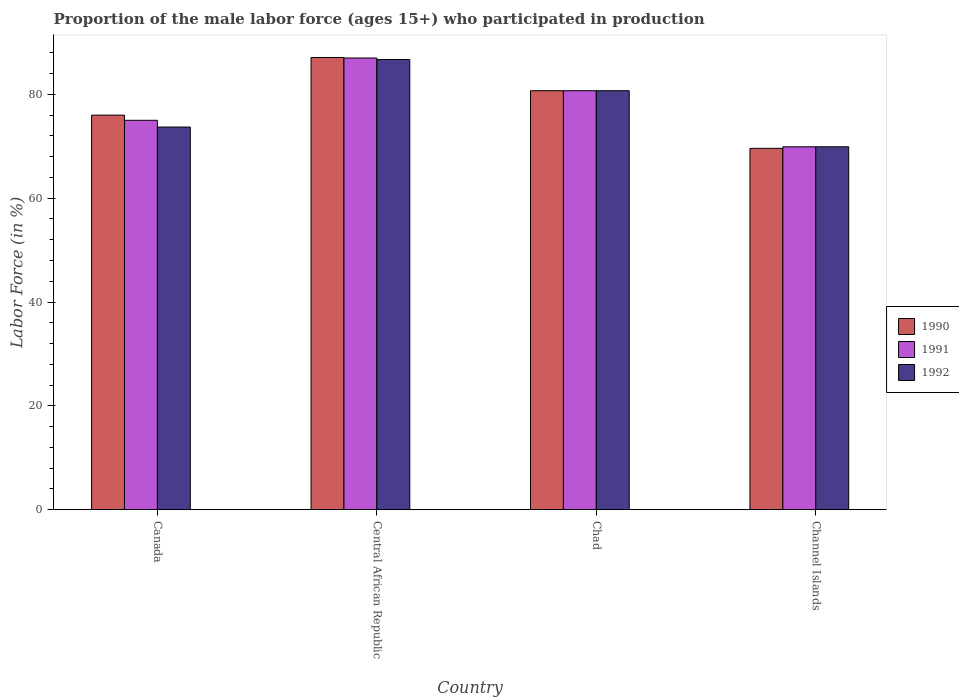How many different coloured bars are there?
Offer a very short reply. 3. How many groups of bars are there?
Your response must be concise. 4. How many bars are there on the 3rd tick from the right?
Keep it short and to the point. 3. What is the label of the 1st group of bars from the left?
Offer a very short reply. Canada. In how many cases, is the number of bars for a given country not equal to the number of legend labels?
Your answer should be compact. 0. What is the proportion of the male labor force who participated in production in 1992 in Chad?
Your answer should be compact. 80.7. Across all countries, what is the minimum proportion of the male labor force who participated in production in 1992?
Ensure brevity in your answer.  69.9. In which country was the proportion of the male labor force who participated in production in 1991 maximum?
Offer a terse response. Central African Republic. In which country was the proportion of the male labor force who participated in production in 1992 minimum?
Offer a terse response. Channel Islands. What is the total proportion of the male labor force who participated in production in 1990 in the graph?
Make the answer very short. 313.4. What is the difference between the proportion of the male labor force who participated in production in 1992 in Canada and that in Chad?
Your answer should be compact. -7. What is the difference between the proportion of the male labor force who participated in production in 1990 in Chad and the proportion of the male labor force who participated in production in 1991 in Central African Republic?
Your response must be concise. -6.3. What is the average proportion of the male labor force who participated in production in 1990 per country?
Your response must be concise. 78.35. What is the difference between the proportion of the male labor force who participated in production of/in 1992 and proportion of the male labor force who participated in production of/in 1991 in Central African Republic?
Offer a terse response. -0.3. In how many countries, is the proportion of the male labor force who participated in production in 1992 greater than 8 %?
Offer a terse response. 4. What is the ratio of the proportion of the male labor force who participated in production in 1991 in Canada to that in Central African Republic?
Keep it short and to the point. 0.86. Is the proportion of the male labor force who participated in production in 1991 in Canada less than that in Central African Republic?
Ensure brevity in your answer.  Yes. Is the difference between the proportion of the male labor force who participated in production in 1992 in Central African Republic and Chad greater than the difference between the proportion of the male labor force who participated in production in 1991 in Central African Republic and Chad?
Offer a very short reply. No. What is the difference between the highest and the second highest proportion of the male labor force who participated in production in 1992?
Provide a succinct answer. 7. What is the difference between the highest and the lowest proportion of the male labor force who participated in production in 1990?
Offer a very short reply. 17.5. Is the sum of the proportion of the male labor force who participated in production in 1992 in Canada and Channel Islands greater than the maximum proportion of the male labor force who participated in production in 1990 across all countries?
Ensure brevity in your answer.  Yes. What does the 3rd bar from the right in Central African Republic represents?
Your answer should be compact. 1990. How many bars are there?
Provide a succinct answer. 12. What is the difference between two consecutive major ticks on the Y-axis?
Your response must be concise. 20. Are the values on the major ticks of Y-axis written in scientific E-notation?
Offer a very short reply. No. Does the graph contain grids?
Offer a very short reply. No. Where does the legend appear in the graph?
Offer a terse response. Center right. How many legend labels are there?
Your response must be concise. 3. What is the title of the graph?
Give a very brief answer. Proportion of the male labor force (ages 15+) who participated in production. What is the Labor Force (in %) in 1992 in Canada?
Your answer should be very brief. 73.7. What is the Labor Force (in %) in 1990 in Central African Republic?
Give a very brief answer. 87.1. What is the Labor Force (in %) in 1991 in Central African Republic?
Keep it short and to the point. 87. What is the Labor Force (in %) of 1992 in Central African Republic?
Your response must be concise. 86.7. What is the Labor Force (in %) of 1990 in Chad?
Ensure brevity in your answer.  80.7. What is the Labor Force (in %) of 1991 in Chad?
Provide a succinct answer. 80.7. What is the Labor Force (in %) in 1992 in Chad?
Provide a succinct answer. 80.7. What is the Labor Force (in %) in 1990 in Channel Islands?
Provide a succinct answer. 69.6. What is the Labor Force (in %) of 1991 in Channel Islands?
Give a very brief answer. 69.9. What is the Labor Force (in %) in 1992 in Channel Islands?
Provide a short and direct response. 69.9. Across all countries, what is the maximum Labor Force (in %) in 1990?
Provide a succinct answer. 87.1. Across all countries, what is the maximum Labor Force (in %) of 1991?
Keep it short and to the point. 87. Across all countries, what is the maximum Labor Force (in %) in 1992?
Your answer should be very brief. 86.7. Across all countries, what is the minimum Labor Force (in %) in 1990?
Provide a succinct answer. 69.6. Across all countries, what is the minimum Labor Force (in %) of 1991?
Keep it short and to the point. 69.9. Across all countries, what is the minimum Labor Force (in %) of 1992?
Give a very brief answer. 69.9. What is the total Labor Force (in %) in 1990 in the graph?
Your answer should be very brief. 313.4. What is the total Labor Force (in %) in 1991 in the graph?
Offer a terse response. 312.6. What is the total Labor Force (in %) in 1992 in the graph?
Your answer should be very brief. 311. What is the difference between the Labor Force (in %) of 1991 in Canada and that in Central African Republic?
Keep it short and to the point. -12. What is the difference between the Labor Force (in %) in 1992 in Canada and that in Channel Islands?
Make the answer very short. 3.8. What is the difference between the Labor Force (in %) in 1991 in Central African Republic and that in Chad?
Keep it short and to the point. 6.3. What is the difference between the Labor Force (in %) in 1992 in Central African Republic and that in Chad?
Your answer should be compact. 6. What is the difference between the Labor Force (in %) in 1990 in Central African Republic and that in Channel Islands?
Your answer should be very brief. 17.5. What is the difference between the Labor Force (in %) in 1991 in Chad and that in Channel Islands?
Ensure brevity in your answer.  10.8. What is the difference between the Labor Force (in %) of 1992 in Chad and that in Channel Islands?
Keep it short and to the point. 10.8. What is the difference between the Labor Force (in %) of 1990 in Canada and the Labor Force (in %) of 1991 in Central African Republic?
Ensure brevity in your answer.  -11. What is the difference between the Labor Force (in %) in 1991 in Canada and the Labor Force (in %) in 1992 in Central African Republic?
Offer a terse response. -11.7. What is the difference between the Labor Force (in %) of 1990 in Canada and the Labor Force (in %) of 1992 in Chad?
Offer a terse response. -4.7. What is the difference between the Labor Force (in %) of 1991 in Canada and the Labor Force (in %) of 1992 in Chad?
Keep it short and to the point. -5.7. What is the difference between the Labor Force (in %) of 1990 in Canada and the Labor Force (in %) of 1991 in Channel Islands?
Offer a terse response. 6.1. What is the difference between the Labor Force (in %) of 1990 in Canada and the Labor Force (in %) of 1992 in Channel Islands?
Provide a succinct answer. 6.1. What is the difference between the Labor Force (in %) of 1991 in Canada and the Labor Force (in %) of 1992 in Channel Islands?
Provide a short and direct response. 5.1. What is the difference between the Labor Force (in %) in 1990 in Central African Republic and the Labor Force (in %) in 1991 in Chad?
Keep it short and to the point. 6.4. What is the difference between the Labor Force (in %) of 1991 in Central African Republic and the Labor Force (in %) of 1992 in Chad?
Provide a succinct answer. 6.3. What is the difference between the Labor Force (in %) in 1990 in Central African Republic and the Labor Force (in %) in 1991 in Channel Islands?
Provide a short and direct response. 17.2. What is the difference between the Labor Force (in %) in 1990 in Chad and the Labor Force (in %) in 1991 in Channel Islands?
Give a very brief answer. 10.8. What is the difference between the Labor Force (in %) in 1990 in Chad and the Labor Force (in %) in 1992 in Channel Islands?
Offer a very short reply. 10.8. What is the difference between the Labor Force (in %) in 1991 in Chad and the Labor Force (in %) in 1992 in Channel Islands?
Make the answer very short. 10.8. What is the average Labor Force (in %) in 1990 per country?
Ensure brevity in your answer.  78.35. What is the average Labor Force (in %) in 1991 per country?
Offer a terse response. 78.15. What is the average Labor Force (in %) in 1992 per country?
Provide a short and direct response. 77.75. What is the difference between the Labor Force (in %) of 1990 and Labor Force (in %) of 1992 in Canada?
Give a very brief answer. 2.3. What is the difference between the Labor Force (in %) in 1991 and Labor Force (in %) in 1992 in Canada?
Keep it short and to the point. 1.3. What is the difference between the Labor Force (in %) in 1990 and Labor Force (in %) in 1991 in Central African Republic?
Your answer should be compact. 0.1. What is the difference between the Labor Force (in %) in 1990 and Labor Force (in %) in 1991 in Chad?
Offer a terse response. 0. What is the difference between the Labor Force (in %) in 1990 and Labor Force (in %) in 1992 in Chad?
Keep it short and to the point. 0. What is the difference between the Labor Force (in %) in 1991 and Labor Force (in %) in 1992 in Chad?
Your response must be concise. 0. What is the difference between the Labor Force (in %) of 1990 and Labor Force (in %) of 1991 in Channel Islands?
Give a very brief answer. -0.3. What is the ratio of the Labor Force (in %) of 1990 in Canada to that in Central African Republic?
Provide a succinct answer. 0.87. What is the ratio of the Labor Force (in %) of 1991 in Canada to that in Central African Republic?
Make the answer very short. 0.86. What is the ratio of the Labor Force (in %) of 1992 in Canada to that in Central African Republic?
Provide a succinct answer. 0.85. What is the ratio of the Labor Force (in %) in 1990 in Canada to that in Chad?
Offer a very short reply. 0.94. What is the ratio of the Labor Force (in %) of 1991 in Canada to that in Chad?
Make the answer very short. 0.93. What is the ratio of the Labor Force (in %) in 1992 in Canada to that in Chad?
Give a very brief answer. 0.91. What is the ratio of the Labor Force (in %) in 1990 in Canada to that in Channel Islands?
Give a very brief answer. 1.09. What is the ratio of the Labor Force (in %) of 1991 in Canada to that in Channel Islands?
Offer a very short reply. 1.07. What is the ratio of the Labor Force (in %) of 1992 in Canada to that in Channel Islands?
Your answer should be compact. 1.05. What is the ratio of the Labor Force (in %) of 1990 in Central African Republic to that in Chad?
Ensure brevity in your answer.  1.08. What is the ratio of the Labor Force (in %) of 1991 in Central African Republic to that in Chad?
Your answer should be compact. 1.08. What is the ratio of the Labor Force (in %) in 1992 in Central African Republic to that in Chad?
Your response must be concise. 1.07. What is the ratio of the Labor Force (in %) in 1990 in Central African Republic to that in Channel Islands?
Your answer should be compact. 1.25. What is the ratio of the Labor Force (in %) in 1991 in Central African Republic to that in Channel Islands?
Provide a short and direct response. 1.24. What is the ratio of the Labor Force (in %) in 1992 in Central African Republic to that in Channel Islands?
Make the answer very short. 1.24. What is the ratio of the Labor Force (in %) of 1990 in Chad to that in Channel Islands?
Make the answer very short. 1.16. What is the ratio of the Labor Force (in %) in 1991 in Chad to that in Channel Islands?
Give a very brief answer. 1.15. What is the ratio of the Labor Force (in %) of 1992 in Chad to that in Channel Islands?
Your answer should be very brief. 1.15. What is the difference between the highest and the lowest Labor Force (in %) of 1990?
Offer a terse response. 17.5. 